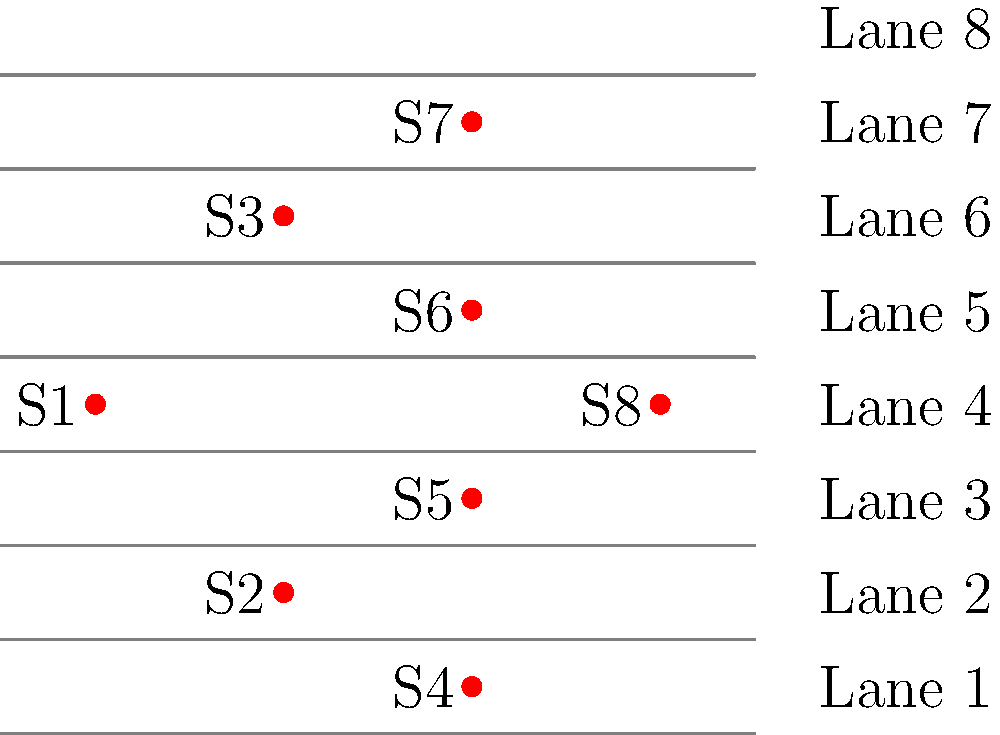In an 8-lane pool, you need to assign lanes for 8 swimmers in a preliminary heat. To minimize the effects of water turbulence, you decide to use a specific pattern where swimmers are placed in every other lane, starting from the center lanes and moving outwards. Given the lane assignments shown in the diagram, what is the mathematical expression for the lane number $L_n$ of the $n$-th fastest swimmer (where $n$ ranges from 1 to 8)? Let's approach this step-by-step:

1) First, observe the pattern of lane assignments in the diagram:
   Swimmer 1 (S1) is in Lane 4
   Swimmer 2 (S2) is in Lane 5
   Swimmer 3 (S3) is in Lane 3
   Swimmer 4 (S4) is in Lane 6
   Swimmer 5 (S5) is in Lane 2
   Swimmer 6 (S6) is in Lane 7
   Swimmer 7 (S7) is in Lane 1
   Swimmer 8 (S8) is in Lane 8

2) We can see that the pattern alternates between adding and subtracting from the center.

3) The center of an 8-lane pool is between lanes 4 and 5. We can represent this as 4.5.

4) For odd-numbered swimmers (1, 3, 5, 7), we subtract from 4.5.
   For even-numbered swimmers (2, 4, 6, 8), we add to 4.5.

5) The amount we add or subtract is half of the swimmer's number, rounded up.
   This can be represented as $\lceil \frac{n}{2} \rceil$.

6) So, our mathematical expression will be:
   $L_n = 4.5 + (-1)^{n+1} \cdot \lceil \frac{n}{2} \rceil$

   Where:
   - $L_n$ is the lane number for the $n$-th fastest swimmer
   - $n$ is the swimmer's rank (1 to 8)
   - $(-1)^{n+1}$ alternates between -1 and 1 for odd and even $n$
   - $\lceil \frac{n}{2} \rceil$ is the ceiling function, giving us the amount to add or subtract

7) This formula correctly gives us:
   For $n=1$: $L_1 = 4.5 + (-1)^2 \cdot \lceil \frac{1}{2} \rceil = 4.5 - 1 = 3.5$, which rounds to lane 4
   For $n=2$: $L_2 = 4.5 + (-1)^3 \cdot \lceil \frac{2}{2} \rceil = 4.5 + 1 = 5.5$, which rounds to lane 5
   And so on for all swimmers.
Answer: $L_n = 4.5 + (-1)^{n+1} \cdot \lceil \frac{n}{2} \rceil$ 